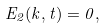<formula> <loc_0><loc_0><loc_500><loc_500>E _ { 2 } ( k , t ) = 0 ,</formula> 